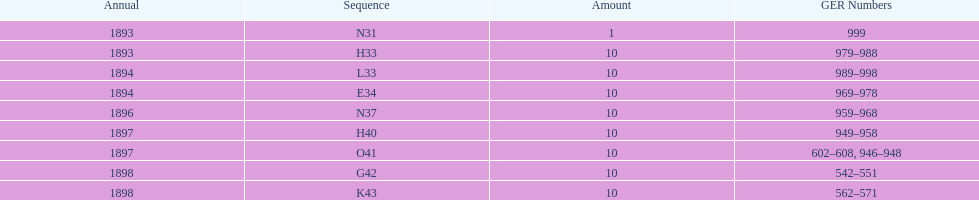How mans years have ger nos below 900? 2. 